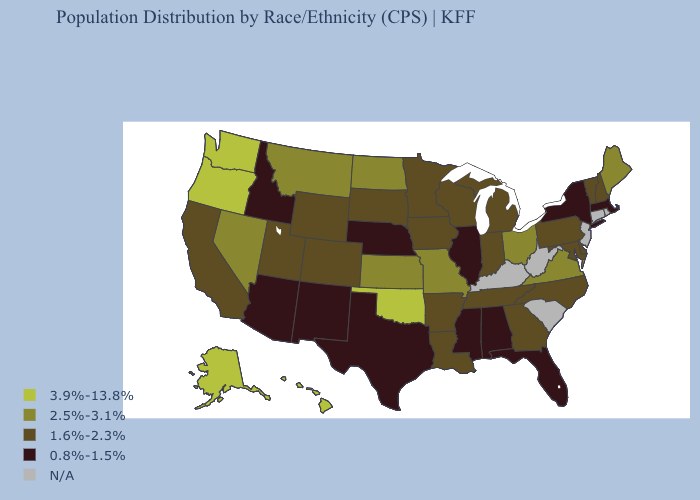Name the states that have a value in the range 3.9%-13.8%?
Be succinct. Alaska, Hawaii, Oklahoma, Oregon, Washington. Among the states that border Montana , does Wyoming have the highest value?
Short answer required. No. Name the states that have a value in the range 0.8%-1.5%?
Quick response, please. Alabama, Arizona, Florida, Idaho, Illinois, Massachusetts, Mississippi, Nebraska, New Mexico, New York, Texas. What is the value of Utah?
Write a very short answer. 1.6%-2.3%. Does the first symbol in the legend represent the smallest category?
Keep it brief. No. Name the states that have a value in the range 1.6%-2.3%?
Keep it brief. Arkansas, California, Colorado, Delaware, Georgia, Indiana, Iowa, Louisiana, Maryland, Michigan, Minnesota, New Hampshire, North Carolina, Pennsylvania, South Dakota, Tennessee, Utah, Vermont, Wisconsin, Wyoming. What is the lowest value in the USA?
Write a very short answer. 0.8%-1.5%. Among the states that border Vermont , which have the lowest value?
Give a very brief answer. Massachusetts, New York. What is the value of Vermont?
Answer briefly. 1.6%-2.3%. Does Illinois have the highest value in the MidWest?
Quick response, please. No. What is the highest value in the USA?
Write a very short answer. 3.9%-13.8%. Among the states that border Pennsylvania , which have the highest value?
Quick response, please. Ohio. What is the highest value in the USA?
Write a very short answer. 3.9%-13.8%. Name the states that have a value in the range 2.5%-3.1%?
Give a very brief answer. Kansas, Maine, Missouri, Montana, Nevada, North Dakota, Ohio, Virginia. 